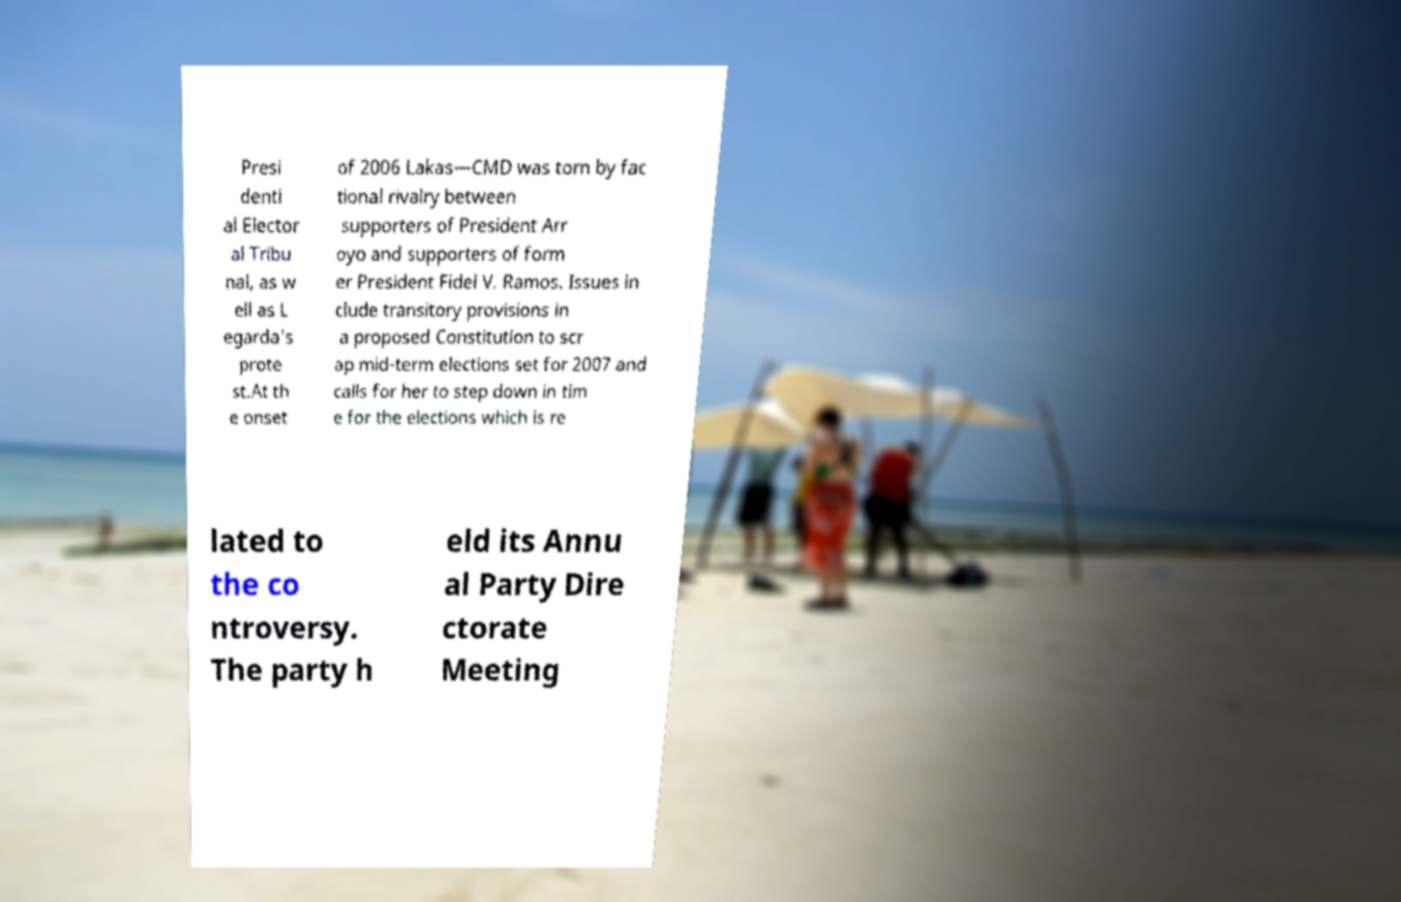Please read and relay the text visible in this image. What does it say? Presi denti al Elector al Tribu nal, as w ell as L egarda's prote st.At th e onset of 2006 Lakas—CMD was torn by fac tional rivalry between supporters of President Arr oyo and supporters of form er President Fidel V. Ramos. Issues in clude transitory provisions in a proposed Constitution to scr ap mid-term elections set for 2007 and calls for her to step down in tim e for the elections which is re lated to the co ntroversy. The party h eld its Annu al Party Dire ctorate Meeting 